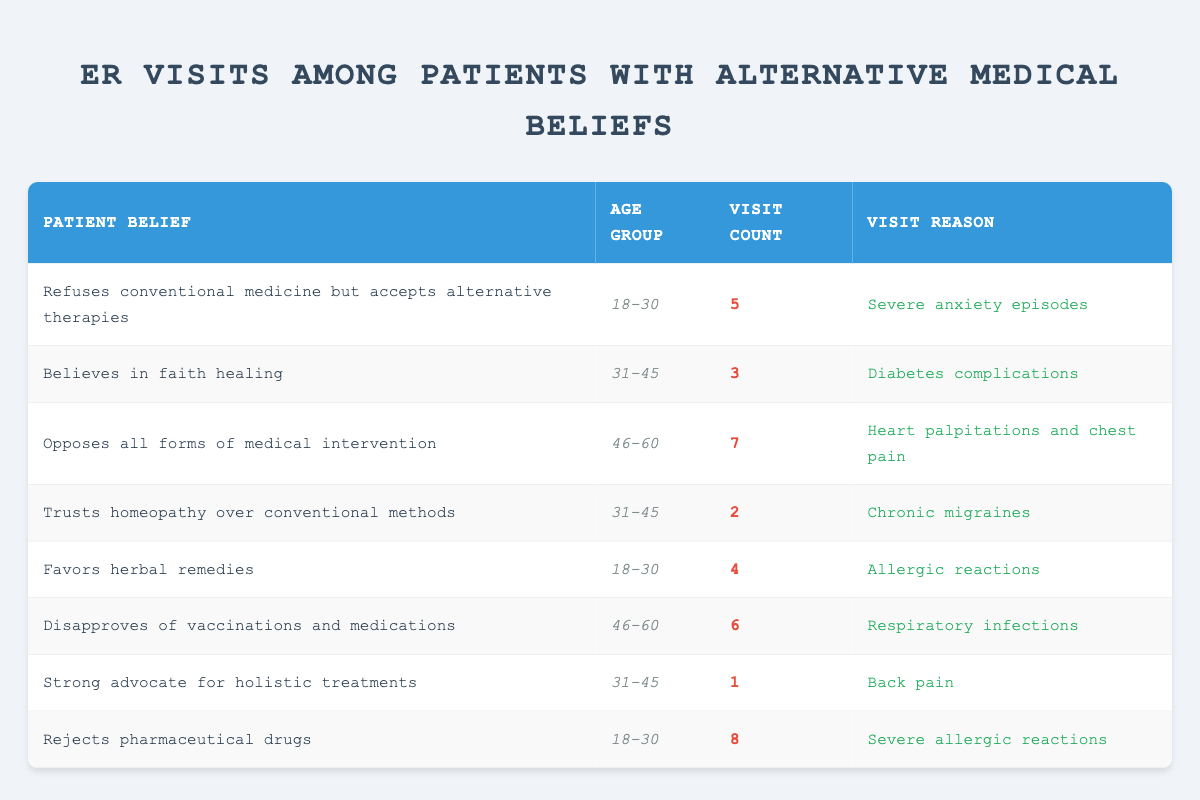What is the total number of emergency room visits for patients aged 18-30? From the table, we can find the visit counts for the age group 18-30. There are two patients: the first has 5 visits (Refuses conventional medicine but accepts alternative therapies) and the second has 4 visits (Favors herbal remedies). Adding these together gives 5 + 4 = 9 visits.
Answer: 9 Which patient belief has the highest visit count? By observing the visit counts in the table, the highest number is from the patient who "Rejects pharmaceutical drugs," with 8 visits. This is more than any other listed belief.
Answer: Rejects pharmaceutical drugs Can we say that all patients aged 46-60 have more than 5 emergency room visits? Looking at the data for the age group 46-60, there are two patients: one with 7 visits (Opposes all forms of medical intervention) and another with 6 visits (Disapproves of vaccinations and medications). Both have more than 5 visits, so the statement is true.
Answer: Yes What is the average number of visits for patients who trust alternative therapies (including homeopathy and herbal remedies)? We sum the visit counts of relevant beliefs: "Trusts homeopathy over conventional methods" has 2 visits, and "Favors herbal remedies" has 4 visits. That totals 2 + 4 = 6 visits. Since there are 2 patients, we find the average: 6 visits / 2 patients = 3 visits.
Answer: 3 How many patients believe in alternative therapies and have reported less than 5 emergency room visits? From the table, we evaluate the relevant patients: "Trusts homeopathy over conventional methods" has 2 visits, and "Strong advocate for holistic treatments" has 1 visit. Thus, there are 2 patients with visit counts less than 5.
Answer: 2 